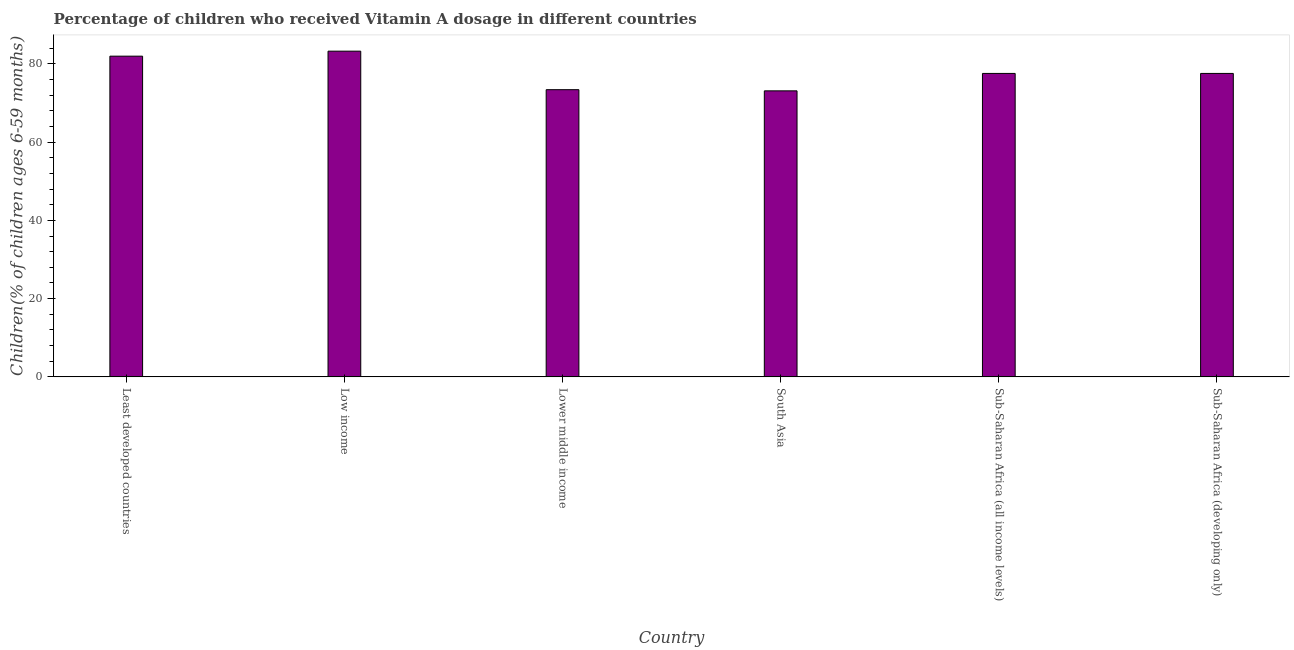What is the title of the graph?
Keep it short and to the point. Percentage of children who received Vitamin A dosage in different countries. What is the label or title of the X-axis?
Offer a terse response. Country. What is the label or title of the Y-axis?
Make the answer very short. Children(% of children ages 6-59 months). What is the vitamin a supplementation coverage rate in Least developed countries?
Provide a short and direct response. 81.97. Across all countries, what is the maximum vitamin a supplementation coverage rate?
Your answer should be compact. 83.25. Across all countries, what is the minimum vitamin a supplementation coverage rate?
Provide a succinct answer. 73.1. In which country was the vitamin a supplementation coverage rate minimum?
Offer a terse response. South Asia. What is the sum of the vitamin a supplementation coverage rate?
Your response must be concise. 466.84. What is the difference between the vitamin a supplementation coverage rate in Lower middle income and Sub-Saharan Africa (developing only)?
Offer a very short reply. -4.16. What is the average vitamin a supplementation coverage rate per country?
Give a very brief answer. 77.81. What is the median vitamin a supplementation coverage rate?
Make the answer very short. 77.56. What is the ratio of the vitamin a supplementation coverage rate in Low income to that in South Asia?
Provide a succinct answer. 1.14. What is the difference between the highest and the second highest vitamin a supplementation coverage rate?
Keep it short and to the point. 1.28. Is the sum of the vitamin a supplementation coverage rate in Low income and Sub-Saharan Africa (developing only) greater than the maximum vitamin a supplementation coverage rate across all countries?
Ensure brevity in your answer.  Yes. What is the difference between the highest and the lowest vitamin a supplementation coverage rate?
Your answer should be very brief. 10.15. In how many countries, is the vitamin a supplementation coverage rate greater than the average vitamin a supplementation coverage rate taken over all countries?
Give a very brief answer. 2. What is the difference between two consecutive major ticks on the Y-axis?
Your answer should be very brief. 20. What is the Children(% of children ages 6-59 months) of Least developed countries?
Keep it short and to the point. 81.97. What is the Children(% of children ages 6-59 months) of Low income?
Provide a succinct answer. 83.25. What is the Children(% of children ages 6-59 months) of Lower middle income?
Offer a terse response. 73.4. What is the Children(% of children ages 6-59 months) of South Asia?
Ensure brevity in your answer.  73.1. What is the Children(% of children ages 6-59 months) in Sub-Saharan Africa (all income levels)?
Provide a succinct answer. 77.56. What is the Children(% of children ages 6-59 months) in Sub-Saharan Africa (developing only)?
Your answer should be compact. 77.56. What is the difference between the Children(% of children ages 6-59 months) in Least developed countries and Low income?
Make the answer very short. -1.28. What is the difference between the Children(% of children ages 6-59 months) in Least developed countries and Lower middle income?
Offer a very short reply. 8.57. What is the difference between the Children(% of children ages 6-59 months) in Least developed countries and South Asia?
Keep it short and to the point. 8.87. What is the difference between the Children(% of children ages 6-59 months) in Least developed countries and Sub-Saharan Africa (all income levels)?
Your response must be concise. 4.41. What is the difference between the Children(% of children ages 6-59 months) in Least developed countries and Sub-Saharan Africa (developing only)?
Make the answer very short. 4.41. What is the difference between the Children(% of children ages 6-59 months) in Low income and Lower middle income?
Provide a short and direct response. 9.85. What is the difference between the Children(% of children ages 6-59 months) in Low income and South Asia?
Your answer should be compact. 10.15. What is the difference between the Children(% of children ages 6-59 months) in Low income and Sub-Saharan Africa (all income levels)?
Your answer should be very brief. 5.69. What is the difference between the Children(% of children ages 6-59 months) in Low income and Sub-Saharan Africa (developing only)?
Your answer should be compact. 5.69. What is the difference between the Children(% of children ages 6-59 months) in Lower middle income and South Asia?
Offer a terse response. 0.3. What is the difference between the Children(% of children ages 6-59 months) in Lower middle income and Sub-Saharan Africa (all income levels)?
Offer a terse response. -4.16. What is the difference between the Children(% of children ages 6-59 months) in Lower middle income and Sub-Saharan Africa (developing only)?
Provide a short and direct response. -4.16. What is the difference between the Children(% of children ages 6-59 months) in South Asia and Sub-Saharan Africa (all income levels)?
Your answer should be compact. -4.46. What is the difference between the Children(% of children ages 6-59 months) in South Asia and Sub-Saharan Africa (developing only)?
Keep it short and to the point. -4.46. What is the ratio of the Children(% of children ages 6-59 months) in Least developed countries to that in Low income?
Offer a very short reply. 0.98. What is the ratio of the Children(% of children ages 6-59 months) in Least developed countries to that in Lower middle income?
Ensure brevity in your answer.  1.12. What is the ratio of the Children(% of children ages 6-59 months) in Least developed countries to that in South Asia?
Ensure brevity in your answer.  1.12. What is the ratio of the Children(% of children ages 6-59 months) in Least developed countries to that in Sub-Saharan Africa (all income levels)?
Keep it short and to the point. 1.06. What is the ratio of the Children(% of children ages 6-59 months) in Least developed countries to that in Sub-Saharan Africa (developing only)?
Offer a terse response. 1.06. What is the ratio of the Children(% of children ages 6-59 months) in Low income to that in Lower middle income?
Make the answer very short. 1.13. What is the ratio of the Children(% of children ages 6-59 months) in Low income to that in South Asia?
Give a very brief answer. 1.14. What is the ratio of the Children(% of children ages 6-59 months) in Low income to that in Sub-Saharan Africa (all income levels)?
Make the answer very short. 1.07. What is the ratio of the Children(% of children ages 6-59 months) in Low income to that in Sub-Saharan Africa (developing only)?
Offer a very short reply. 1.07. What is the ratio of the Children(% of children ages 6-59 months) in Lower middle income to that in Sub-Saharan Africa (all income levels)?
Provide a succinct answer. 0.95. What is the ratio of the Children(% of children ages 6-59 months) in Lower middle income to that in Sub-Saharan Africa (developing only)?
Provide a short and direct response. 0.95. What is the ratio of the Children(% of children ages 6-59 months) in South Asia to that in Sub-Saharan Africa (all income levels)?
Provide a succinct answer. 0.94. What is the ratio of the Children(% of children ages 6-59 months) in South Asia to that in Sub-Saharan Africa (developing only)?
Offer a very short reply. 0.94. What is the ratio of the Children(% of children ages 6-59 months) in Sub-Saharan Africa (all income levels) to that in Sub-Saharan Africa (developing only)?
Provide a short and direct response. 1. 